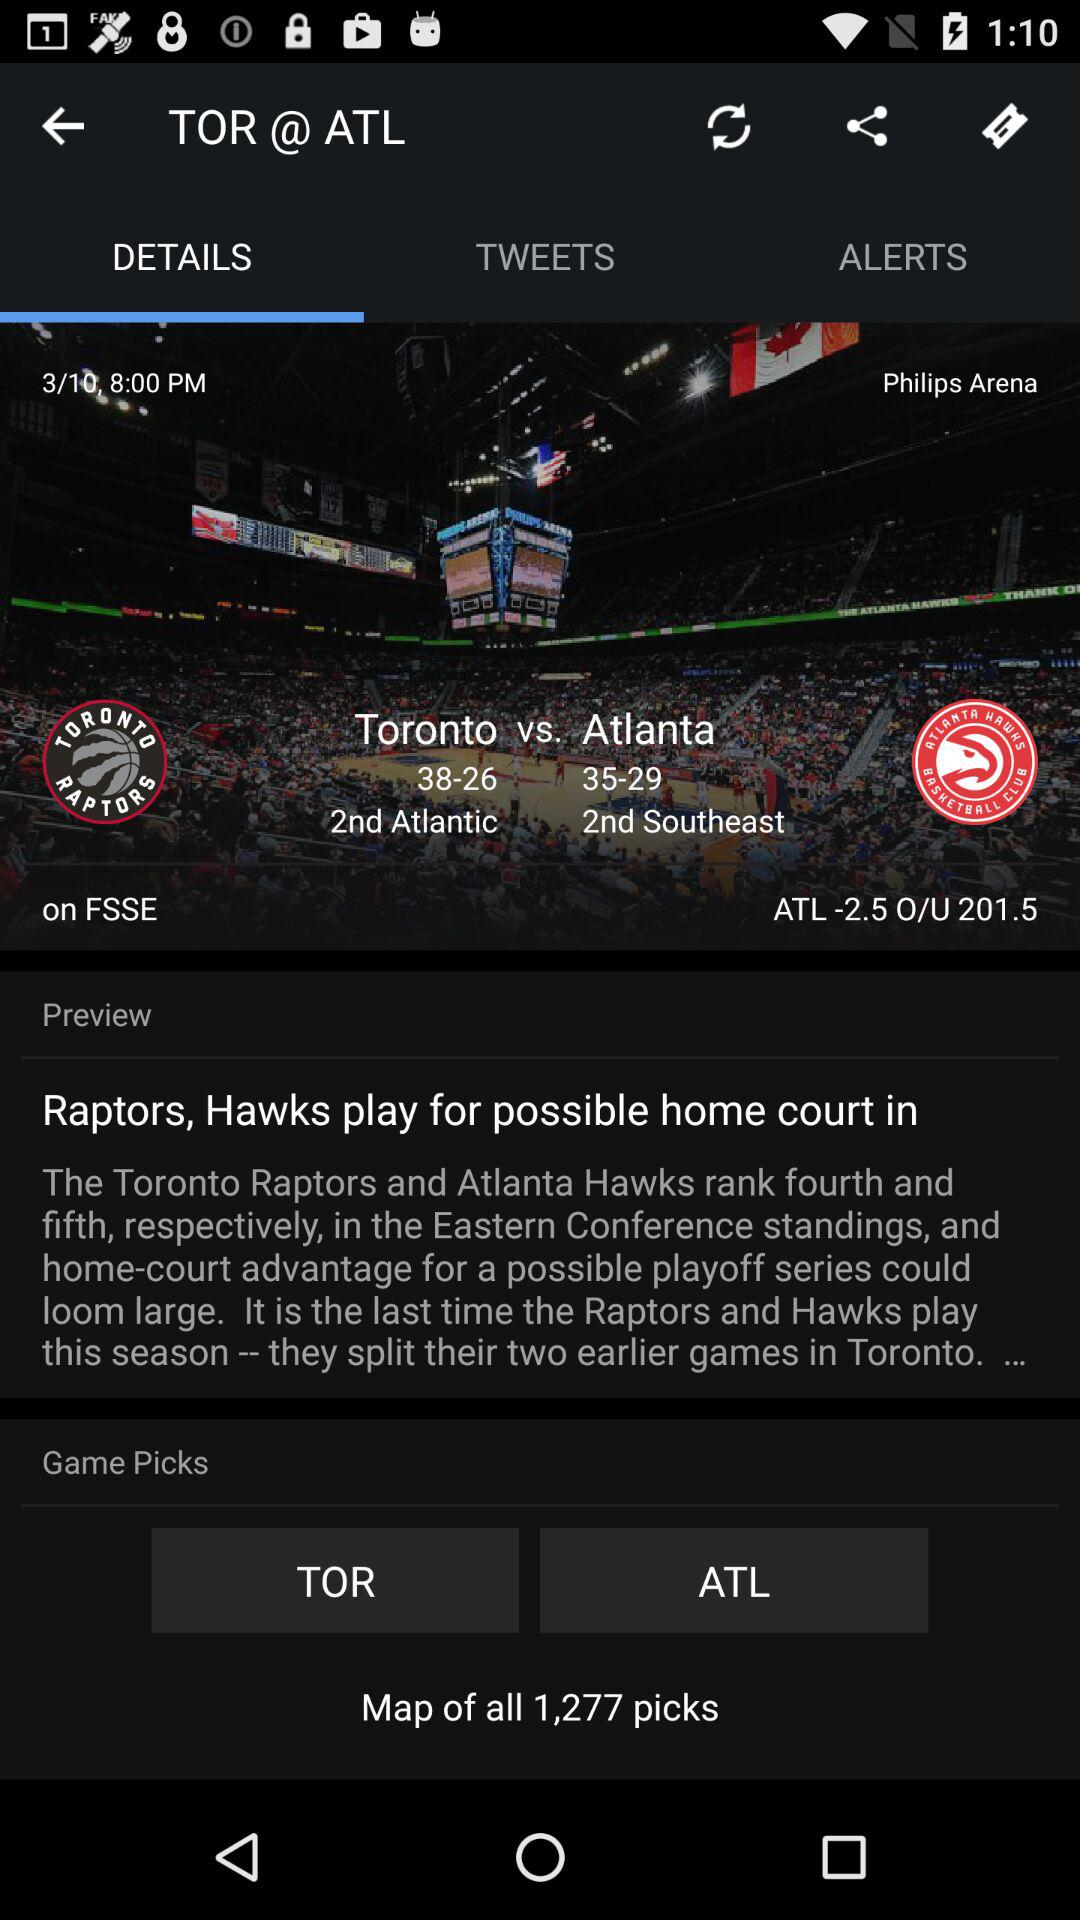What is the current page out of total pages? The current page is 3. 